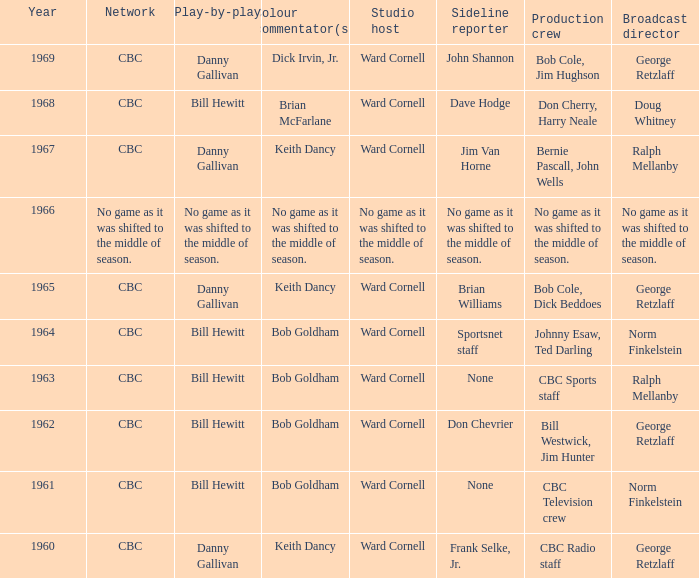Who did the play-by-play with studio host Ward Cornell and color commentator Bob Goldham? Bill Hewitt, Bill Hewitt, Bill Hewitt, Bill Hewitt. 